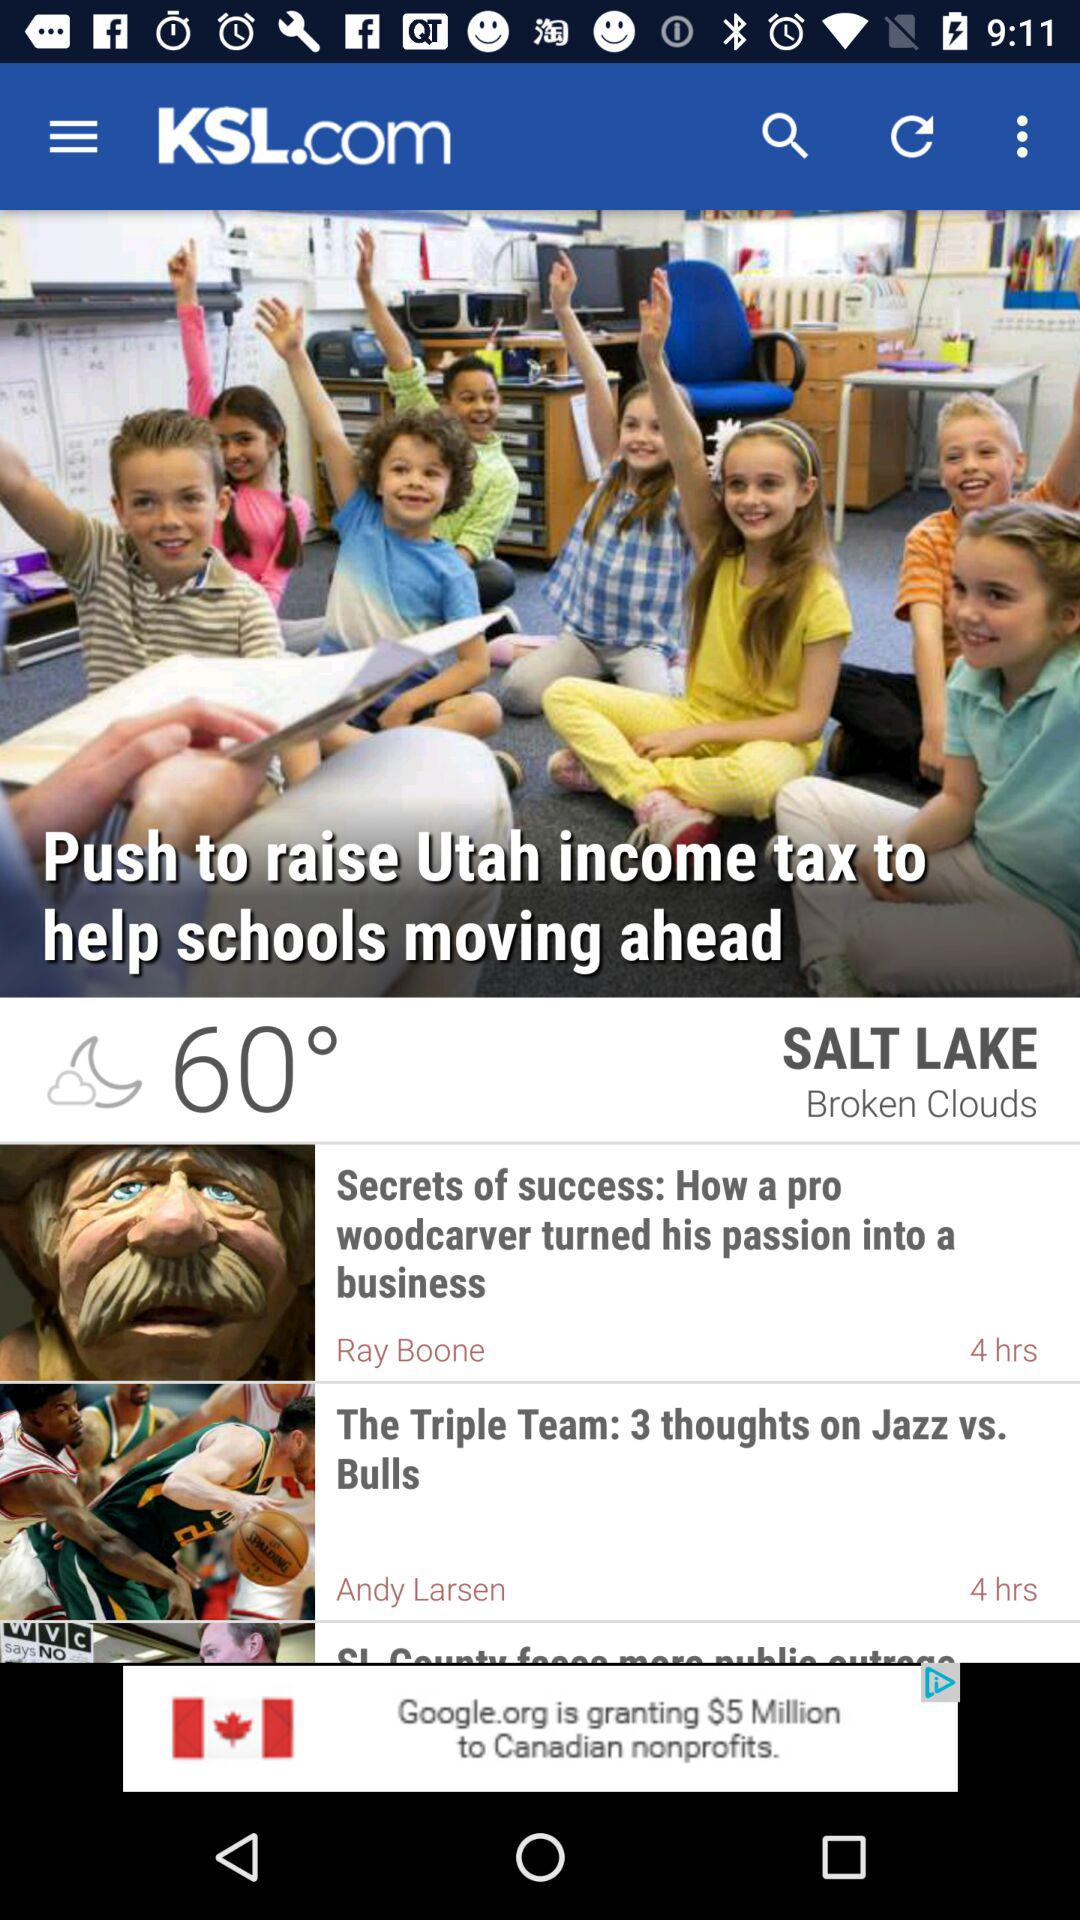Will it reach 60 degrees tomorrow as well?
When the provided information is insufficient, respond with <no answer>. <no answer> 